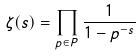<formula> <loc_0><loc_0><loc_500><loc_500>\zeta ( s ) = \prod _ { p \in P } \frac { 1 } { 1 - p ^ { - s } }</formula> 